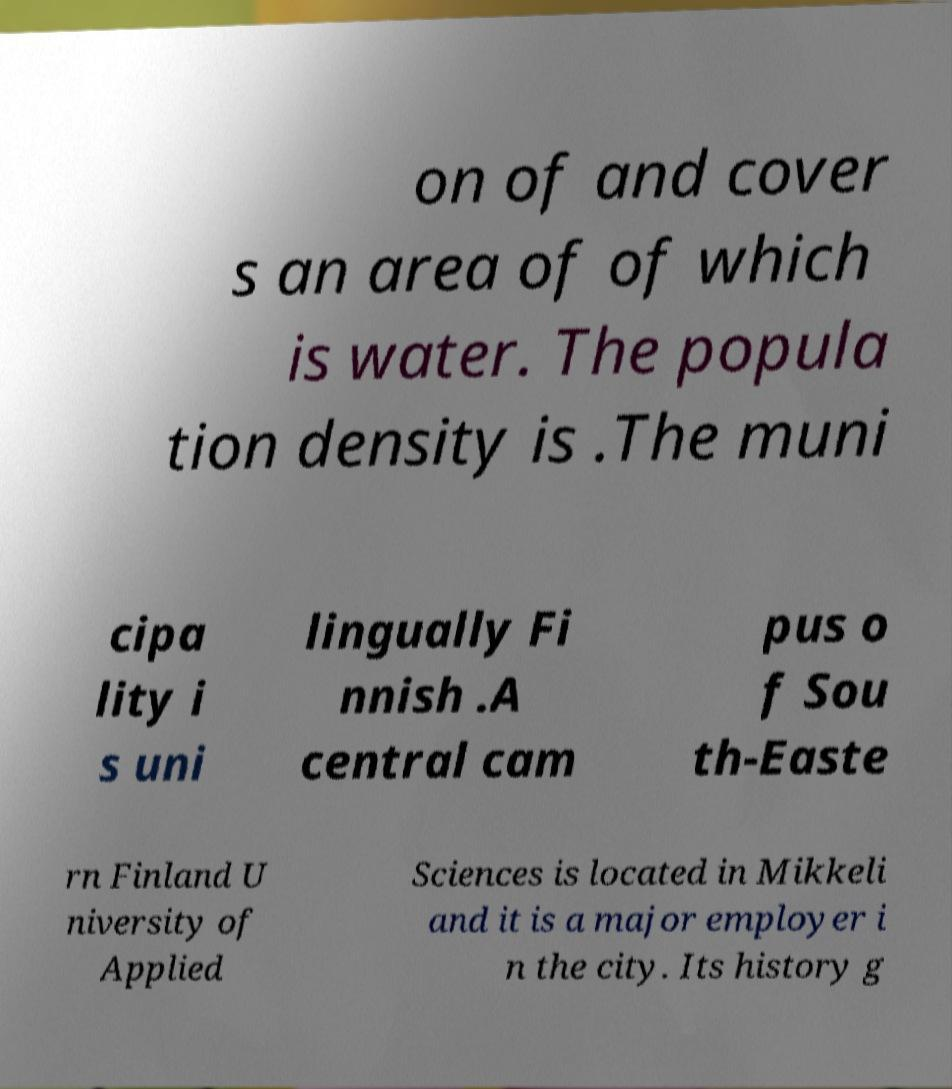Please identify and transcribe the text found in this image. on of and cover s an area of of which is water. The popula tion density is .The muni cipa lity i s uni lingually Fi nnish .A central cam pus o f Sou th-Easte rn Finland U niversity of Applied Sciences is located in Mikkeli and it is a major employer i n the city. Its history g 